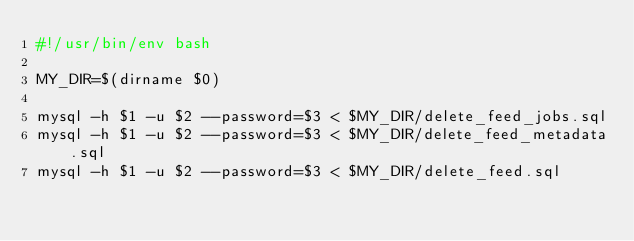<code> <loc_0><loc_0><loc_500><loc_500><_Bash_>#!/usr/bin/env bash

MY_DIR=$(dirname $0)

mysql -h $1 -u $2 --password=$3 < $MY_DIR/delete_feed_jobs.sql
mysql -h $1 -u $2 --password=$3 < $MY_DIR/delete_feed_metadata.sql
mysql -h $1 -u $2 --password=$3 < $MY_DIR/delete_feed.sql</code> 